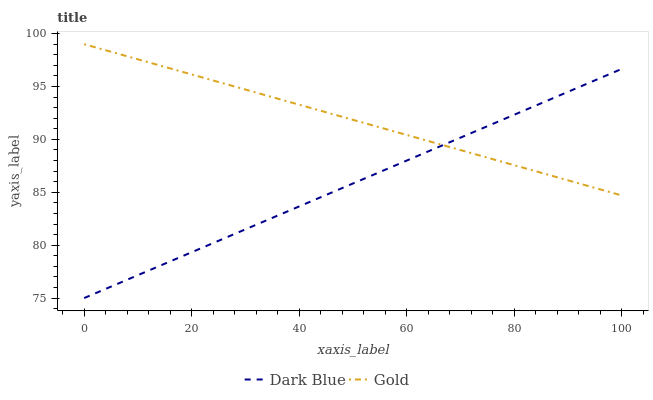Does Dark Blue have the minimum area under the curve?
Answer yes or no. Yes. Does Gold have the maximum area under the curve?
Answer yes or no. Yes. Does Gold have the minimum area under the curve?
Answer yes or no. No. Is Gold the smoothest?
Answer yes or no. Yes. Is Dark Blue the roughest?
Answer yes or no. Yes. Is Gold the roughest?
Answer yes or no. No. Does Dark Blue have the lowest value?
Answer yes or no. Yes. Does Gold have the lowest value?
Answer yes or no. No. Does Gold have the highest value?
Answer yes or no. Yes. Does Gold intersect Dark Blue?
Answer yes or no. Yes. Is Gold less than Dark Blue?
Answer yes or no. No. Is Gold greater than Dark Blue?
Answer yes or no. No. 